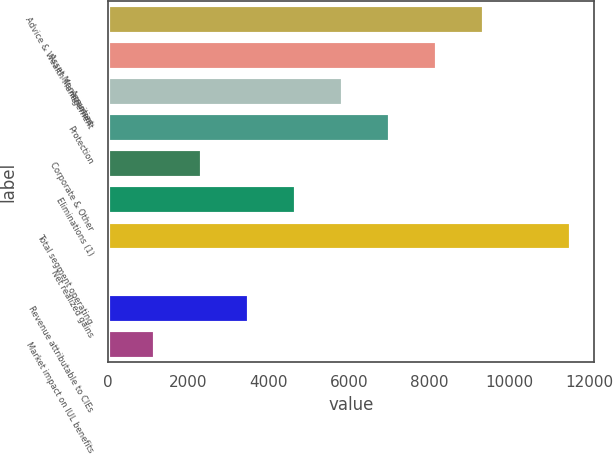<chart> <loc_0><loc_0><loc_500><loc_500><bar_chart><fcel>Advice & Wealth Management<fcel>Asset Management<fcel>Annuities<fcel>Protection<fcel>Corporate & Other<fcel>Eliminations (1)<fcel>Total segment operating<fcel>Net realized gains<fcel>Revenue attributable to CIEs<fcel>Market impact on IUL benefits<nl><fcel>9358<fcel>8189<fcel>5851<fcel>7020<fcel>2344<fcel>4682<fcel>11535<fcel>6<fcel>3513<fcel>1175<nl></chart> 